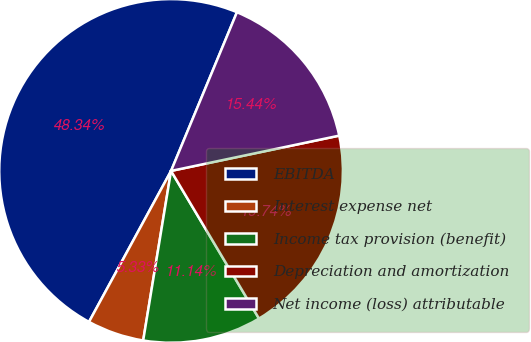Convert chart to OTSL. <chart><loc_0><loc_0><loc_500><loc_500><pie_chart><fcel>EBITDA<fcel>Interest expense net<fcel>Income tax provision (benefit)<fcel>Depreciation and amortization<fcel>Net income (loss) attributable<nl><fcel>48.33%<fcel>5.33%<fcel>11.14%<fcel>19.74%<fcel>15.44%<nl></chart> 